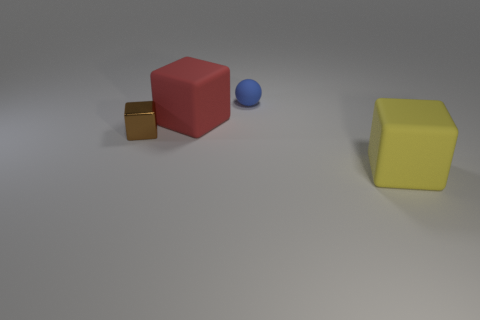Are there fewer tiny brown metal things than large gray shiny spheres?
Your response must be concise. No. Is the cube in front of the small brown shiny block made of the same material as the large thing that is behind the small brown metal block?
Ensure brevity in your answer.  Yes. Is the number of small blue rubber things to the right of the big yellow object less than the number of large green matte spheres?
Your answer should be very brief. No. How many big yellow blocks are left of the rubber block to the left of the sphere?
Ensure brevity in your answer.  0. How big is the block that is both right of the small block and in front of the big red rubber block?
Offer a very short reply. Large. Is there anything else that has the same material as the blue ball?
Ensure brevity in your answer.  Yes. Is the material of the brown cube the same as the big red thing that is behind the small brown shiny cube?
Ensure brevity in your answer.  No. Are there fewer small blue objects right of the tiny brown block than large rubber blocks that are behind the tiny rubber thing?
Keep it short and to the point. No. There is a large thing that is behind the tiny brown metal thing; what material is it?
Provide a succinct answer. Rubber. What is the color of the cube that is both in front of the red rubber object and behind the big yellow matte block?
Ensure brevity in your answer.  Brown. 